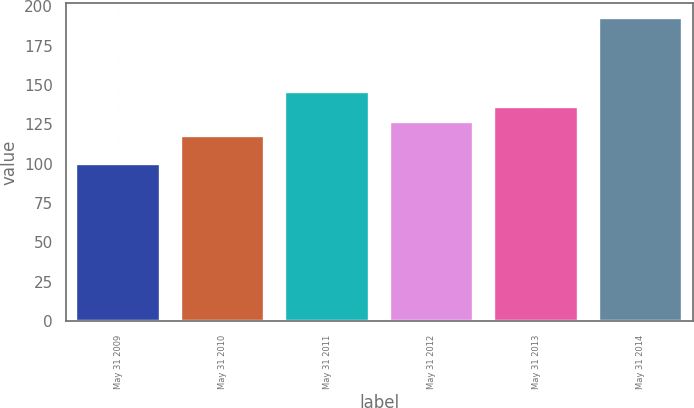Convert chart to OTSL. <chart><loc_0><loc_0><loc_500><loc_500><bar_chart><fcel>May 31 2009<fcel>May 31 2010<fcel>May 31 2011<fcel>May 31 2012<fcel>May 31 2013<fcel>May 31 2014<nl><fcel>100<fcel>117.53<fcel>145.22<fcel>126.76<fcel>135.99<fcel>192.27<nl></chart> 